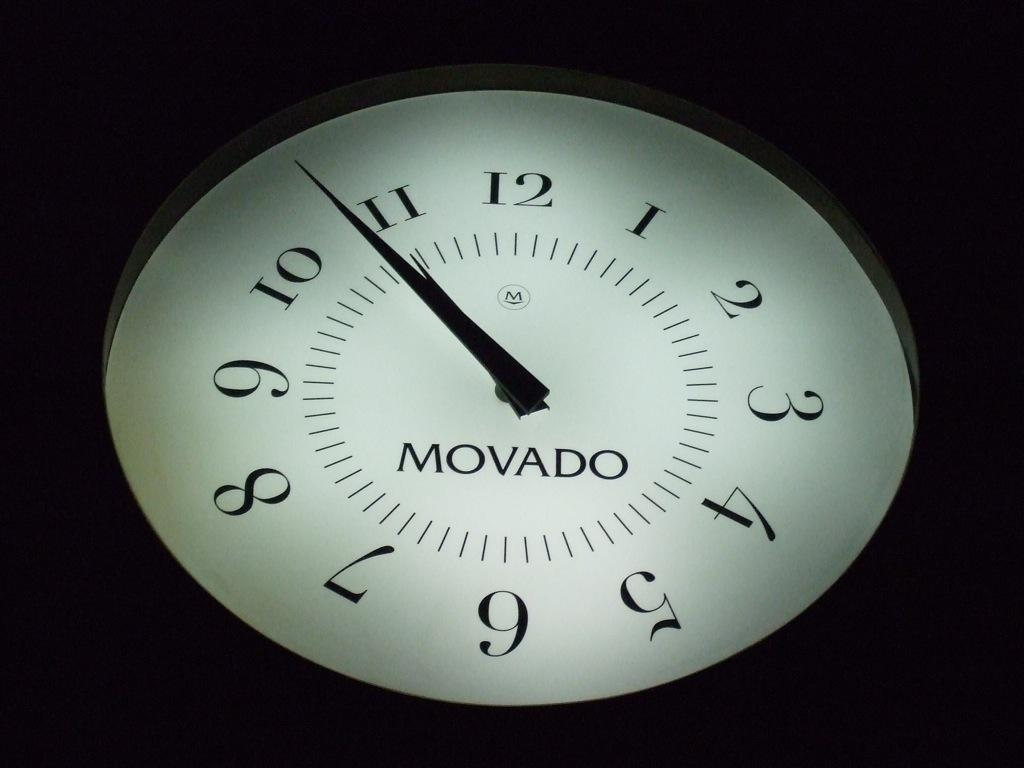Provide a one-sentence caption for the provided image. A Movado clock face glows with light, showing the current time. 